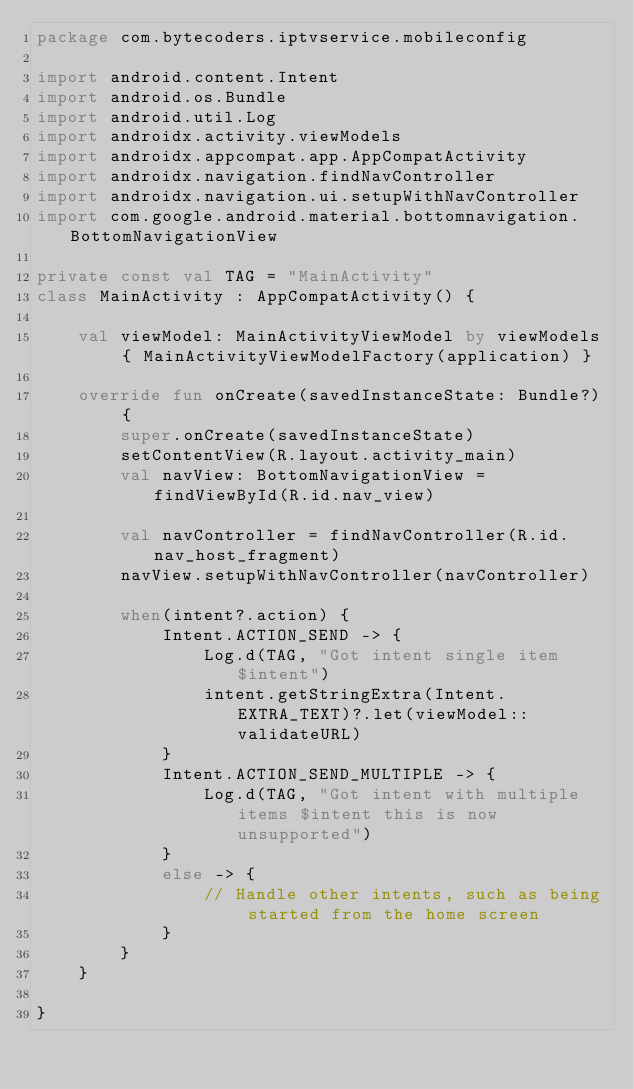<code> <loc_0><loc_0><loc_500><loc_500><_Kotlin_>package com.bytecoders.iptvservice.mobileconfig

import android.content.Intent
import android.os.Bundle
import android.util.Log
import androidx.activity.viewModels
import androidx.appcompat.app.AppCompatActivity
import androidx.navigation.findNavController
import androidx.navigation.ui.setupWithNavController
import com.google.android.material.bottomnavigation.BottomNavigationView

private const val TAG = "MainActivity"
class MainActivity : AppCompatActivity() {

    val viewModel: MainActivityViewModel by viewModels { MainActivityViewModelFactory(application) }

    override fun onCreate(savedInstanceState: Bundle?) {
        super.onCreate(savedInstanceState)
        setContentView(R.layout.activity_main)
        val navView: BottomNavigationView = findViewById(R.id.nav_view)

        val navController = findNavController(R.id.nav_host_fragment)
        navView.setupWithNavController(navController)

        when(intent?.action) {
            Intent.ACTION_SEND -> {
                Log.d(TAG, "Got intent single item $intent")
                intent.getStringExtra(Intent.EXTRA_TEXT)?.let(viewModel::validateURL)
            }
            Intent.ACTION_SEND_MULTIPLE -> {
                Log.d(TAG, "Got intent with multiple items $intent this is now unsupported")
            }
            else -> {
                // Handle other intents, such as being started from the home screen
            }
        }
    }

}
</code> 